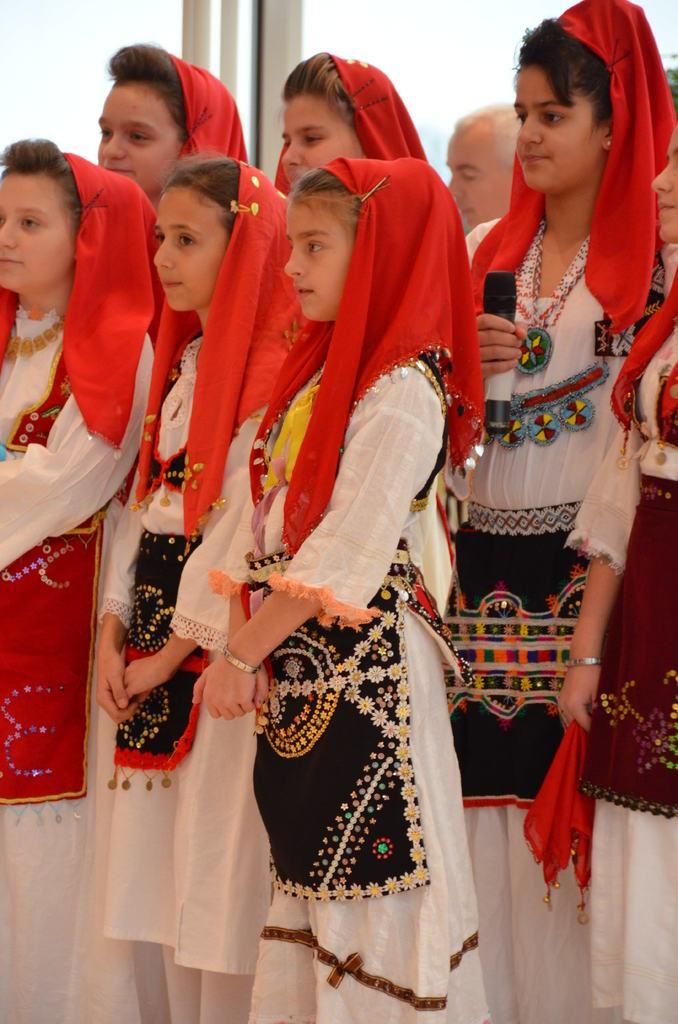How many girls are in the image? There are multiple girls in the image. What are the girls doing in the image? The girls are standing in the image. What are the girls wearing in the image? The girls are wearing traditional costumes in the image. Can you describe the man in the background of the image? There is a man in the background of the image. What is the architectural feature at the top of the image? There is a glass door at the top of the image. What type of house is depicted in the image? There is no house depicted in the image; it features multiple girls standing in traditional costumes, a man in the background, and a glass door at the top. How do the girls escape from the quicksand in the image? There is no quicksand present in the image, so the girls do not need to escape from it. 